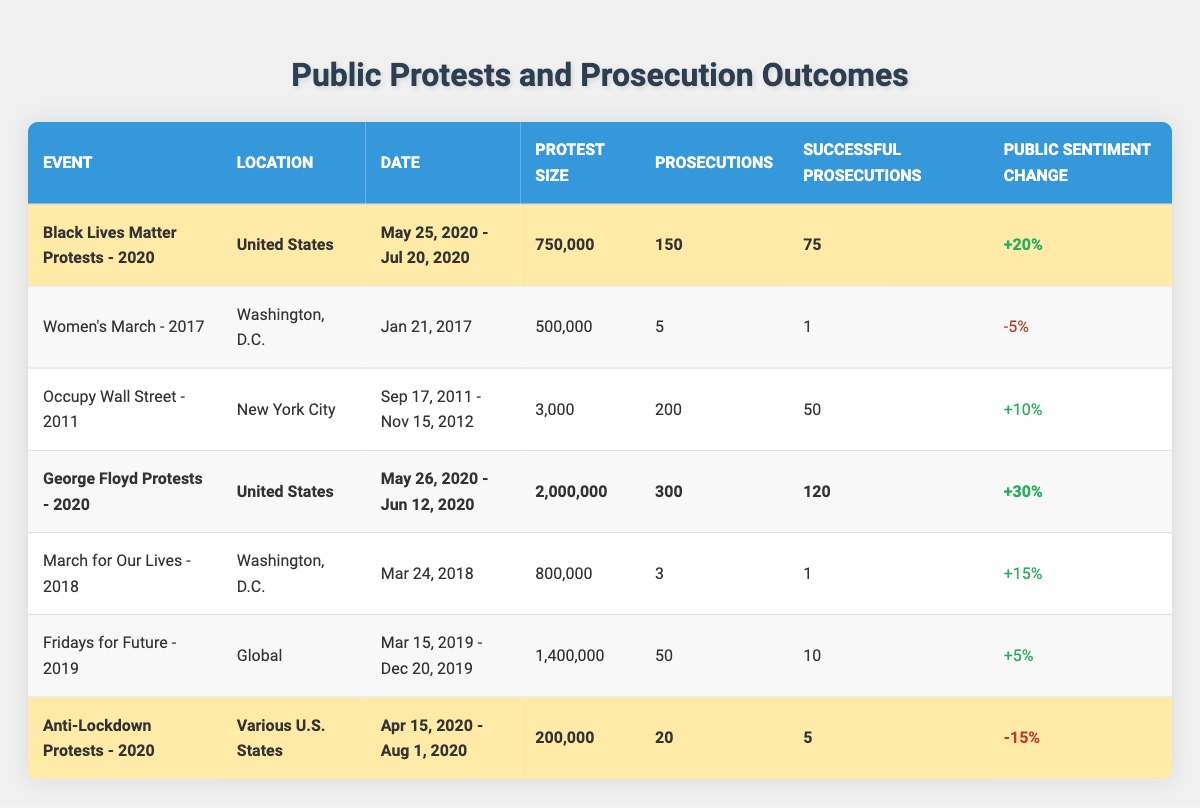What was the largest protest by attendance? The largest protest by attendance can be found by comparing the "Protest Size" column. The George Floyd Protests had a size of 2,000,000, which is the highest among all events listed.
Answer: George Floyd Protests - 2020 How many successful prosecutions were there for the Black Lives Matter Protests? The number of successful prosecutions for the Black Lives Matter Protests is given directly in the "Successful Prosecutions" column and is 75.
Answer: 75 What was the public sentiment change for the Anti-Lockdown Protests? The public sentiment change for the Anti-Lockdown Protests is shown in the "Public Sentiment Change" column, which states a change of -15%.
Answer: -15% How many total prosecutions were recorded for all protests combined? To find the total prosecutions, sum the "Prosecutions" column: 150 + 5 + 200 + 300 + 3 + 50 + 20 = 728.
Answer: 728 Which protest event had the highest public sentiment change? To find the highest public sentiment change, look at the "Public Sentiment Change" column values and identify the maximum, which is +30% for the George Floyd Protests.
Answer: George Floyd Protests - 2020 How many more successful prosecutions were there for the George Floyd Protests compared to the Black Lives Matter Protests? The successful prosecutions for George Floyd Protests were 120, while for Black Lives Matter Protests it was 75. The difference is 120 - 75 = 45.
Answer: 45 Is it true that all highlighted protest events had a positive public sentiment change? Check the highlighted events: Black Lives Matter Protests +20%, George Floyd Protests +30%, Anti-Lockdown Protests -15%. Since one event has a negative change, the statement is false.
Answer: No What is the average protest size among all the events listed? To calculate the average protest size, sum the "Protest Size" values: 750,000 + 500,000 + 3,000 + 2,000,000 + 800,000 + 1,400,000 + 200,000 = 5,653,000. There are 7 events, so the average is 5,653,000 / 7 ≈ 809,000.
Answer: 809,000 What percentage of prosecutions were successful during the George Floyd Protests? The successful prosecutions during the George Floyd Protests were 120 out of 300 total prosecutions. The percentage is (120 / 300) * 100 = 40%.
Answer: 40% What trend is observed in public sentiment after the Women's March compared to the George Floyd Protests? The Women's March had a public sentiment change of -5%, while the George Floyd Protests had +30%. This indicates a significant increase in positive sentiment for the latter compared to the former.
Answer: Significant increase in positive sentiment 